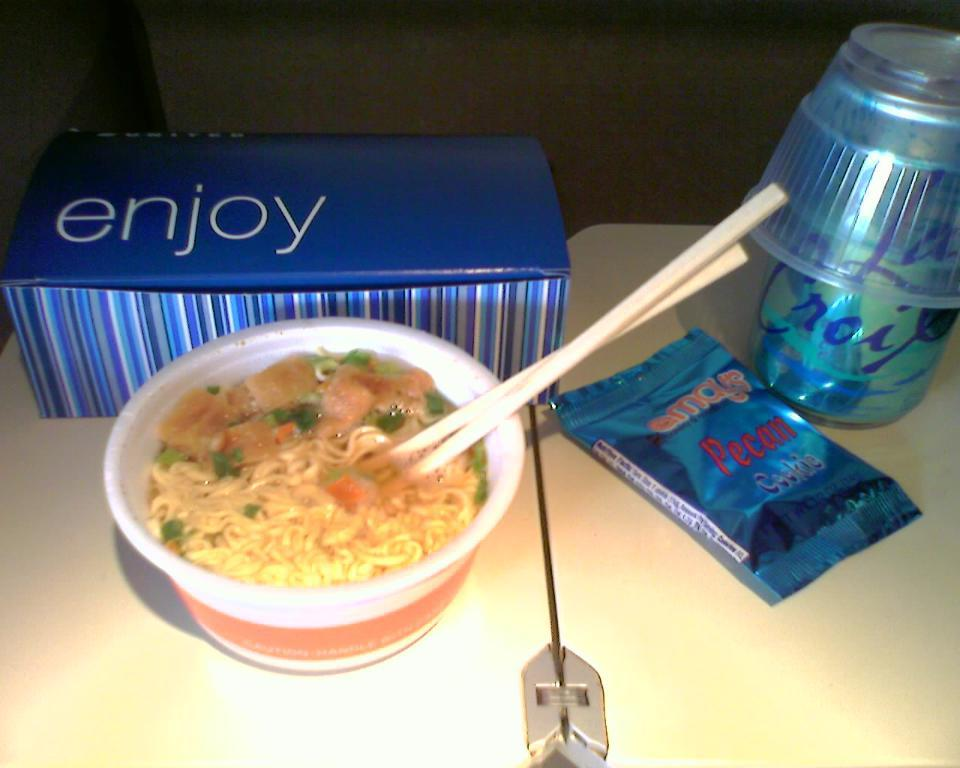<image>
Relay a brief, clear account of the picture shown. A blue striped box with the word "enjoy" on it with a bowl of ramen with chopsticks, a pecan cookie with a La Croix drink on the table. 